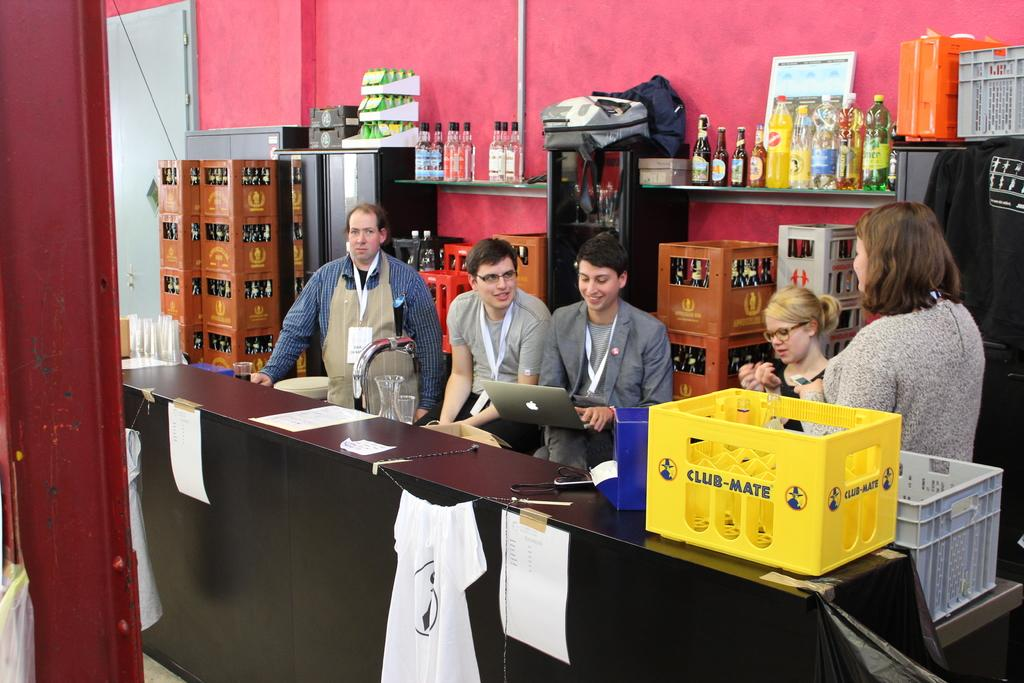<image>
Relay a brief, clear account of the picture shown. a yellow case that has the word club mate on it 